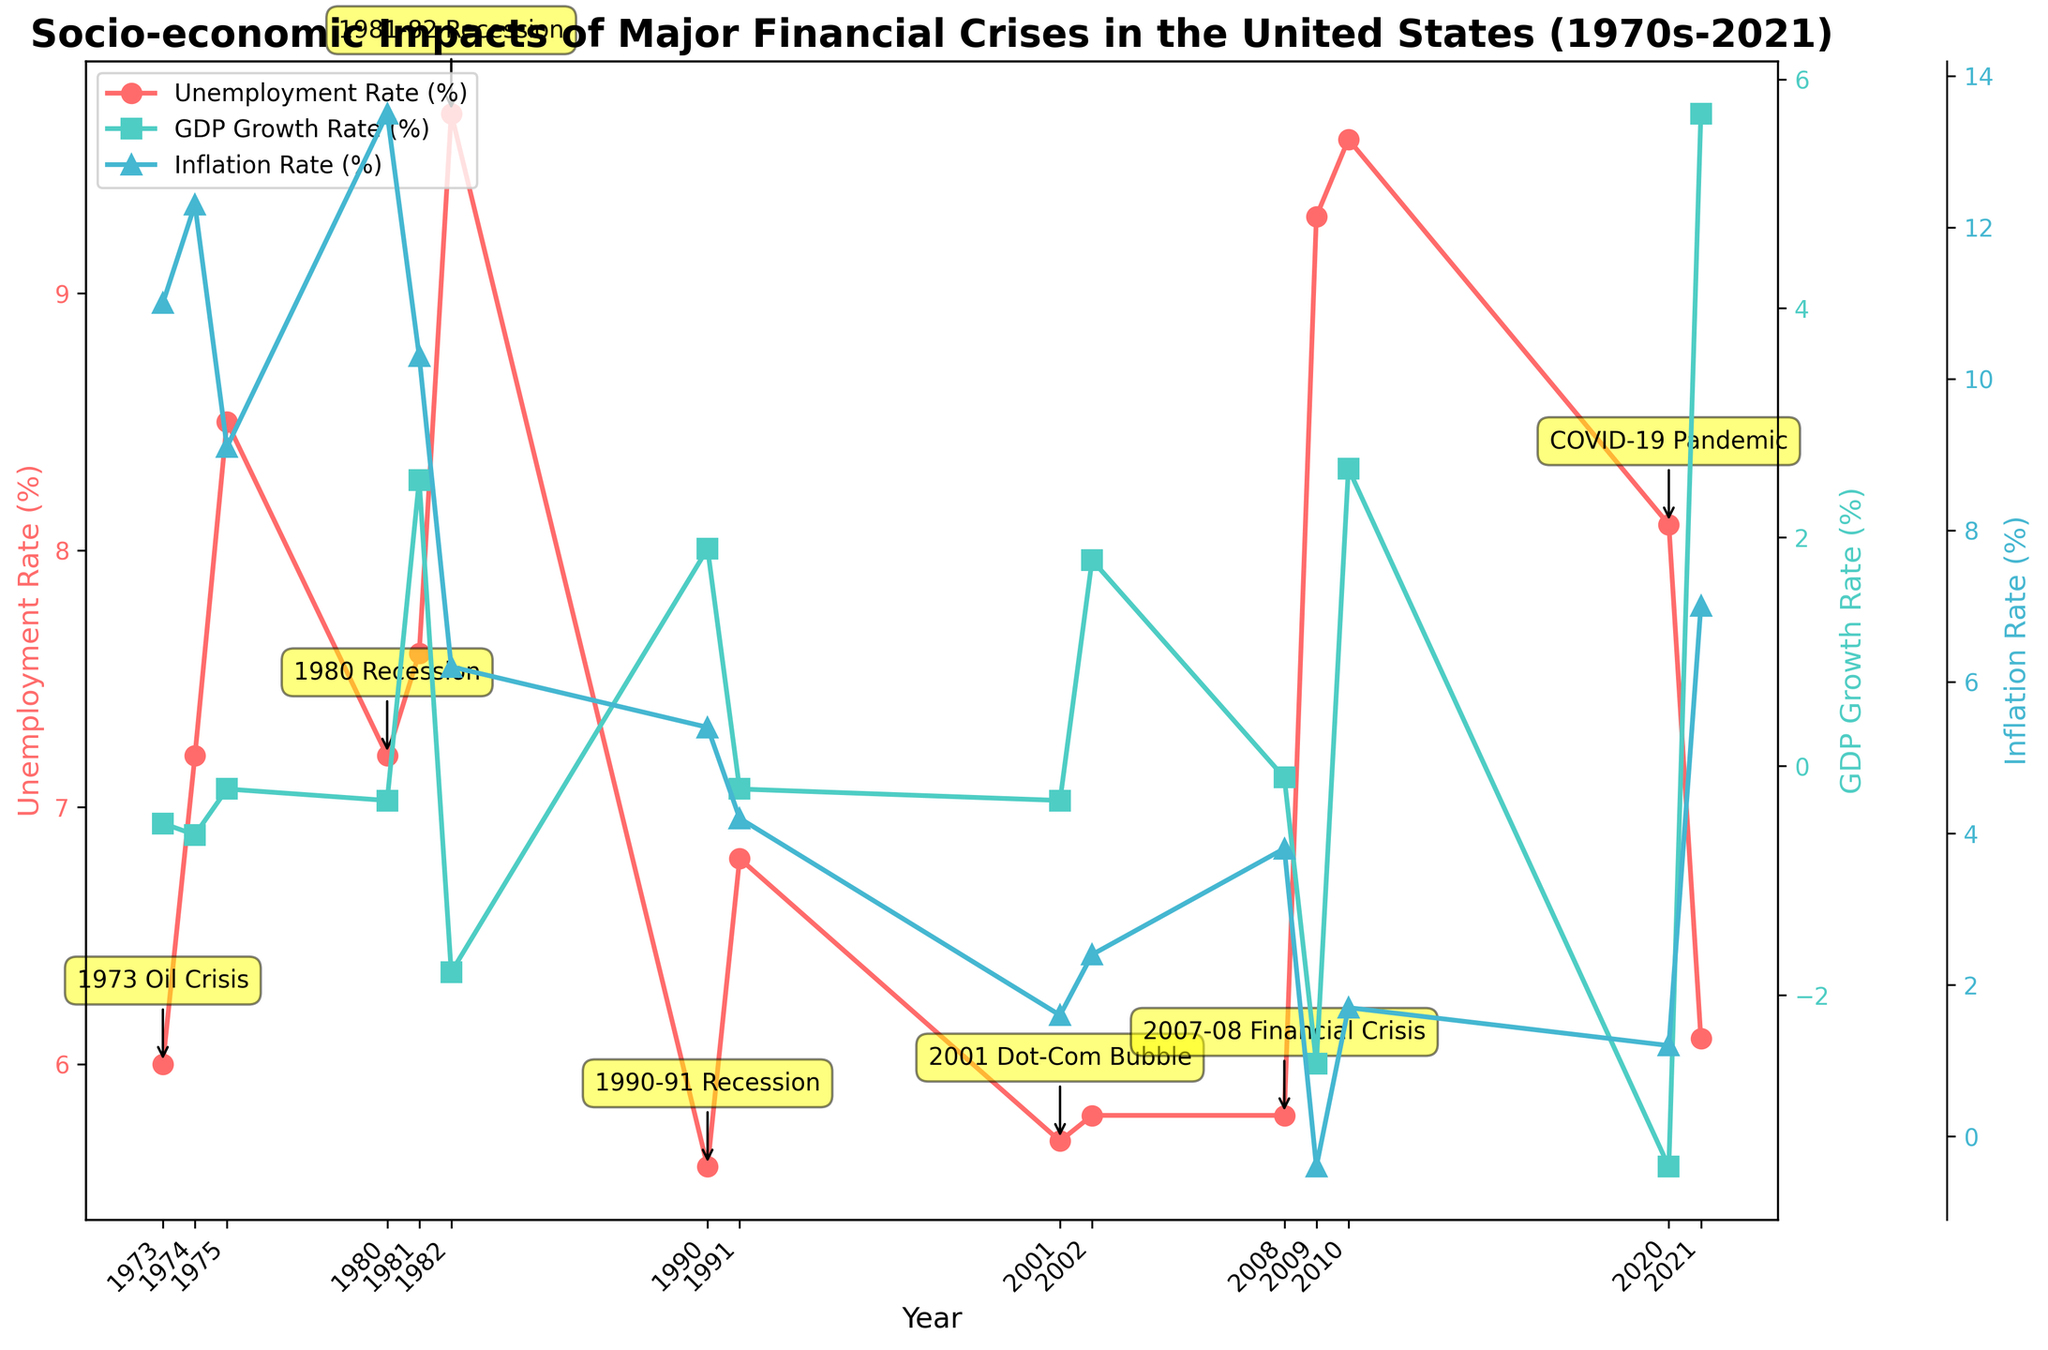What is the highest unemployment rate recorded in the plot? The highest unemployment rate can be identified by looking at the peak of the line representing the unemployment rate.
Answer: 9.7% How did GDP growth rate change during the 1973 Oil Crisis? To find the change in GDP growth rate during the 1973 Oil Crisis, observe the trend of the GDP growth rate line from 1973 to 1975.
Answer: It decreased initially and then increased slightly Which financial crisis is associated with the steepest increase in unemployment rate? Compare the slopes of the unemployment rate line for each financial crisis period. The steepest increase in slope will indicate the crisis with the fastest growing unemployment rate.
Answer: 1981-82 Recession What was the inflation rate in 1980, and how does it compare to 1982? Look at the inflation rate data points for 1980 and 1982 and compare their values.
Answer: 13.5% (1980), 6.2% (1982); 1980 is higher Which financial crisis had the most prolonged period of high unemployment rates? Find the financial crisis period where the unemployment rate sustained high values over multiple data points.
Answer: 2007-08 Financial Crisis How did the unemployment rate change from 2009 to 2010 during the 2007-08 Financial Crisis? Check the unemployment rate data points for the years 2009 and 2010 to assess the change.
Answer: It increased slightly from 9.3% to 9.6% Compare the GDP growth rates during the 1973 Oil Crisis and the COVID-19 Pandemic periods. Identify the GDP growth rates during these two crises and directly compare them.
Answer: Both periods had negative GDP growth rates What is the overall trend in the inflation rate from the 1973 Oil Crisis to the 2021 COVID-19 Pandemic? Analyze the trajectory of the inflation rate line across the entire timeframe of the plot.
Answer: Fluctuating, generally decreasing until a rise in 2021 What was the unemployment rate during the Dot-Com Bubble, and how does it compare to the 2007-08 Financial Crisis? Identify the unemployment rates during the Dot-Com Bubble (2001, 2002) and compare them to the rates during the 2007-08 Financial Crisis (2008-2010).
Answer: Dot-Com: 5.7%-5.8%; 2007-08 Crisis: 5.8%-9.6%; higher during the 2007-08 Crisis Which financial crisis saw a negative inflation rate, and what was that specific rate? Locate the time series data point that indicates a negative inflation rate and identify which financial crisis it corresponds to.
Answer: 2007-08 Financial Crisis; -0.4% in 2009 